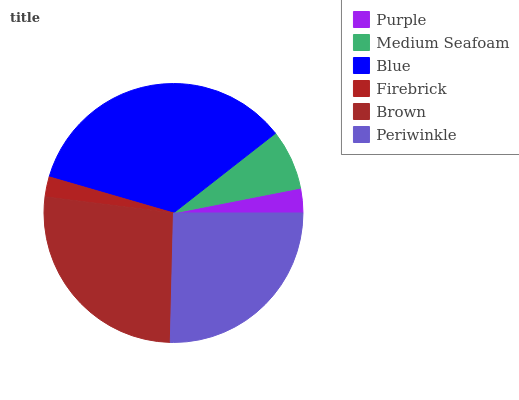Is Firebrick the minimum?
Answer yes or no. Yes. Is Blue the maximum?
Answer yes or no. Yes. Is Medium Seafoam the minimum?
Answer yes or no. No. Is Medium Seafoam the maximum?
Answer yes or no. No. Is Medium Seafoam greater than Purple?
Answer yes or no. Yes. Is Purple less than Medium Seafoam?
Answer yes or no. Yes. Is Purple greater than Medium Seafoam?
Answer yes or no. No. Is Medium Seafoam less than Purple?
Answer yes or no. No. Is Periwinkle the high median?
Answer yes or no. Yes. Is Medium Seafoam the low median?
Answer yes or no. Yes. Is Medium Seafoam the high median?
Answer yes or no. No. Is Periwinkle the low median?
Answer yes or no. No. 